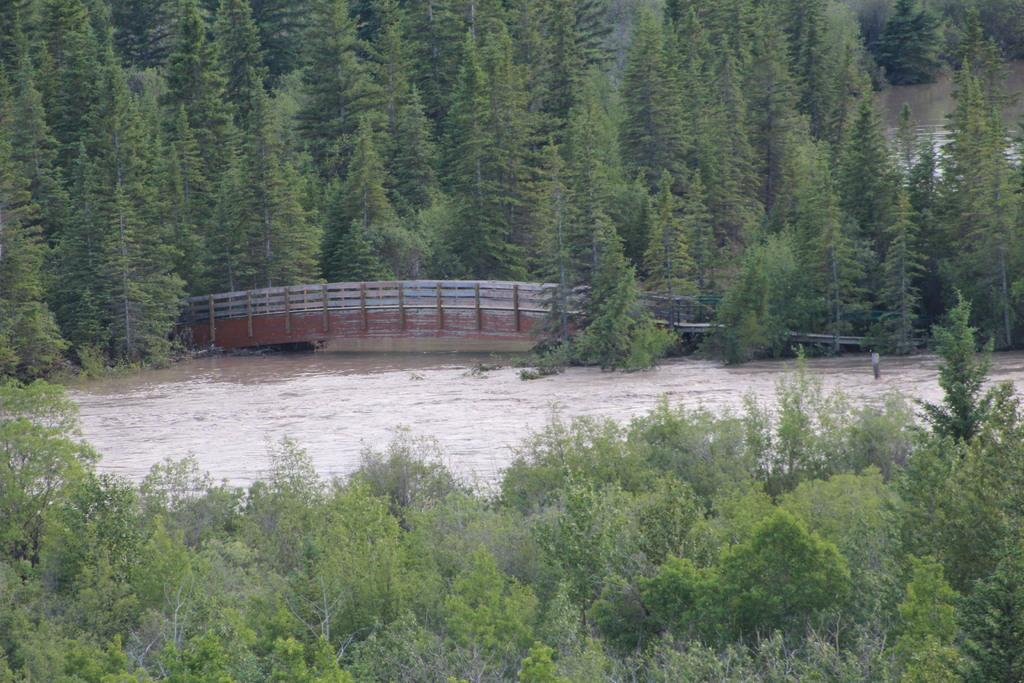What type of vegetation can be seen in the image? There are trees in the front and background of the image. What is located in the middle of the image? There is water and a bridge in the middle of the image. How many trucks are visible on the bridge in the image? There are no trucks present in the image; it features trees, water, and a bridge. Who gave their approval for the construction of the bridge in the image? The image does not provide information about the approval process for the bridge's construction. 